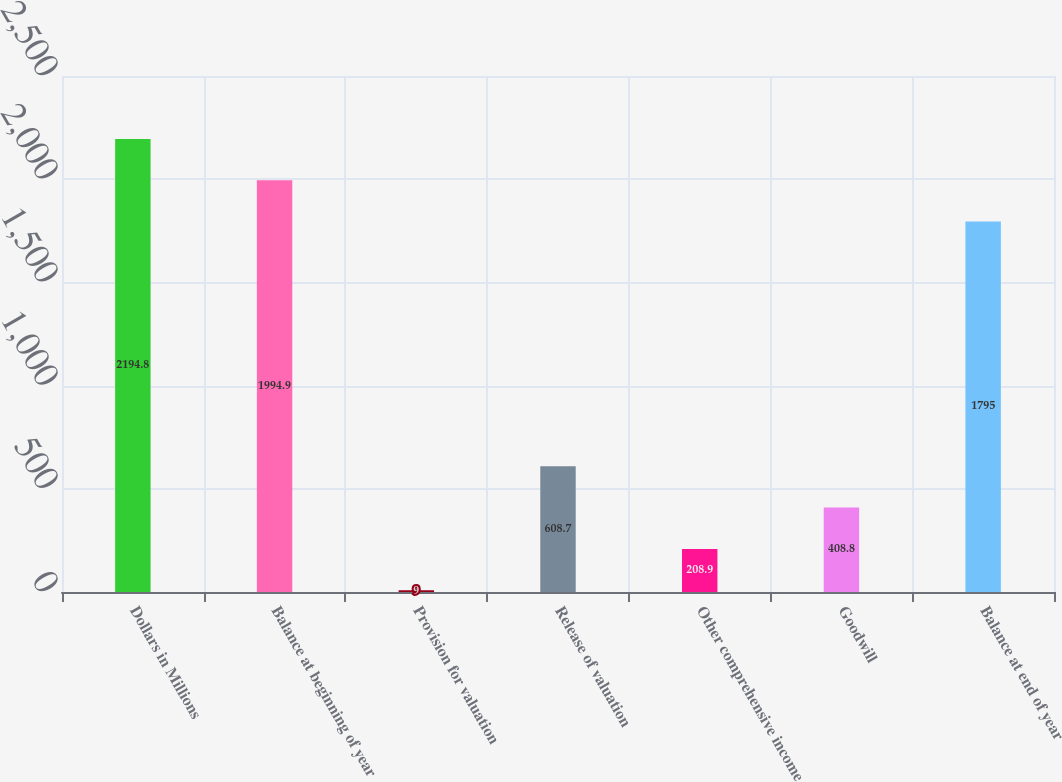<chart> <loc_0><loc_0><loc_500><loc_500><bar_chart><fcel>Dollars in Millions<fcel>Balance at beginning of year<fcel>Provision for valuation<fcel>Release of valuation<fcel>Other comprehensive income<fcel>Goodwill<fcel>Balance at end of year<nl><fcel>2194.8<fcel>1994.9<fcel>9<fcel>608.7<fcel>208.9<fcel>408.8<fcel>1795<nl></chart> 